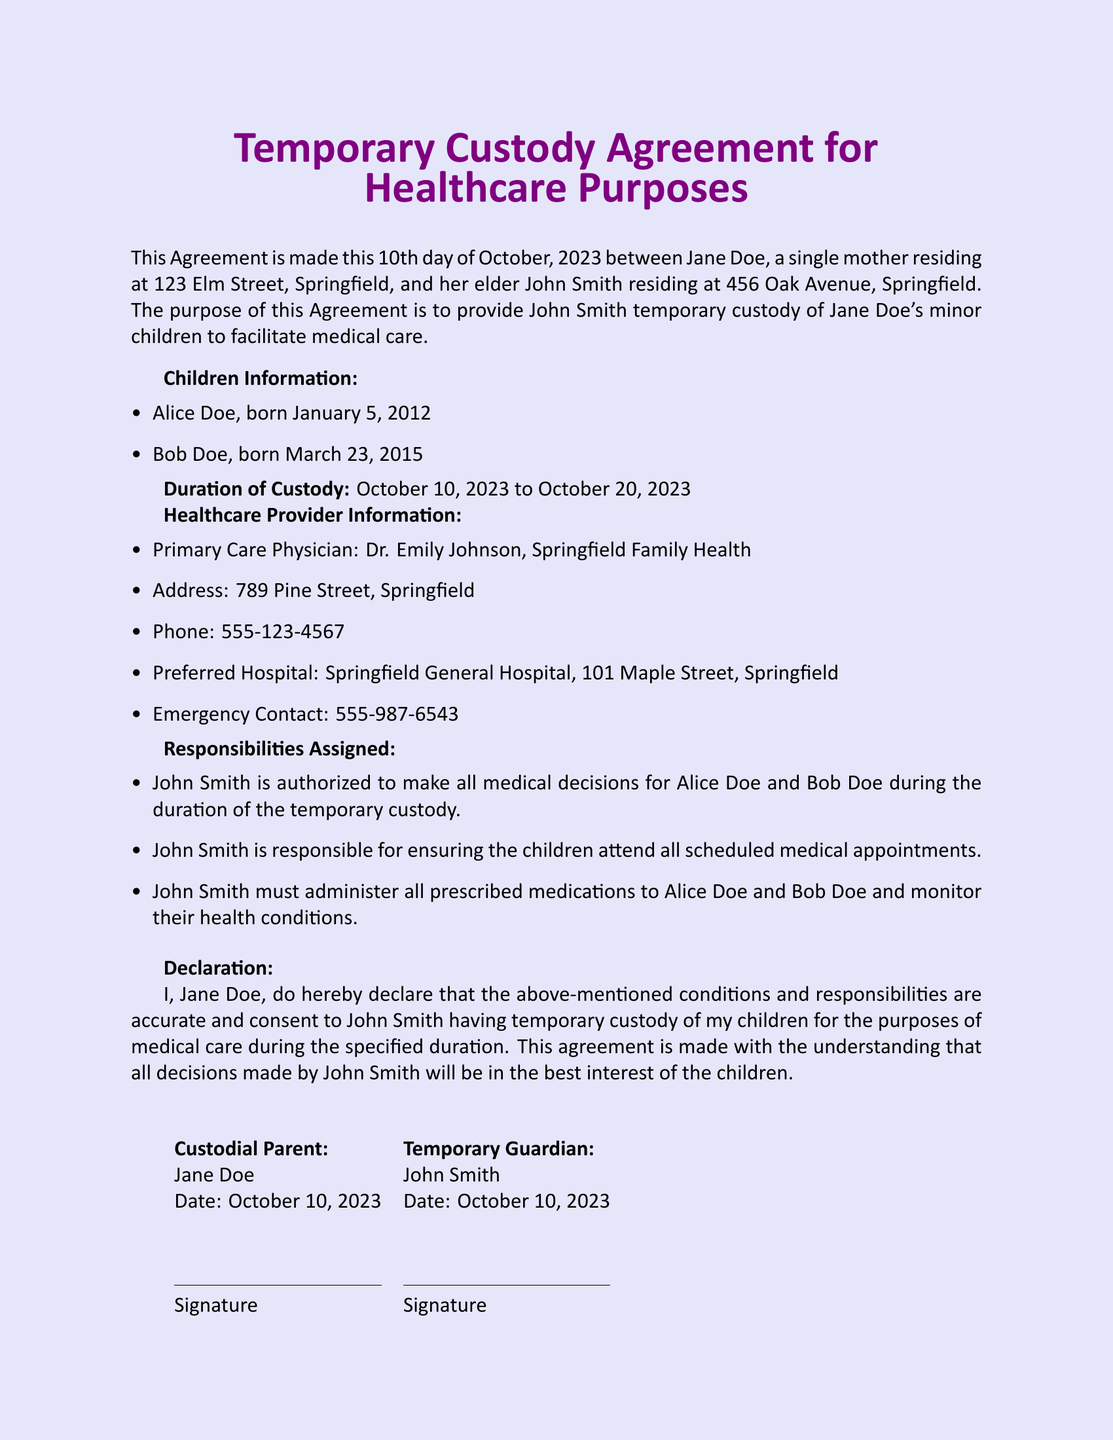What is the full name of the custodial parent? The custodial parent is identified as Jane Doe in the document.
Answer: Jane Doe Who is the temporary guardian? The temporary guardian is specified as John Smith in the document.
Answer: John Smith What is the duration of custody? The document outlines that the custody is from October 10, 2023, to October 20, 2023.
Answer: October 10, 2023 to October 20, 2023 What is the contact number for the primary care physician? The document provides the contact number for Dr. Emily Johnson as 555-123-4567.
Answer: 555-123-4567 Which hospital is preferred for emergencies? The document states that Springfield General Hospital is the preferred hospital.
Answer: Springfield General Hospital What responsibilities does John Smith have as a temporary guardian? John Smith is authorized to make all medical decisions, ensure attendance at appointments, and administer medications.
Answer: Medical decisions, attend appointments, administer medications How many minor children are mentioned in the agreement? The document lists two minor children, Alice Doe and Bob Doe.
Answer: Two When was the agreement made? The agreement date is specified as October 10, 2023, in the document.
Answer: October 10, 2023 What is the address of the healthcare provider? The document indicates that the primary care physician's address is 789 Pine Street, Springfield.
Answer: 789 Pine Street, Springfield 